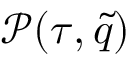<formula> <loc_0><loc_0><loc_500><loc_500>\mathcal { P } ( \tau , { \tilde { q } } )</formula> 